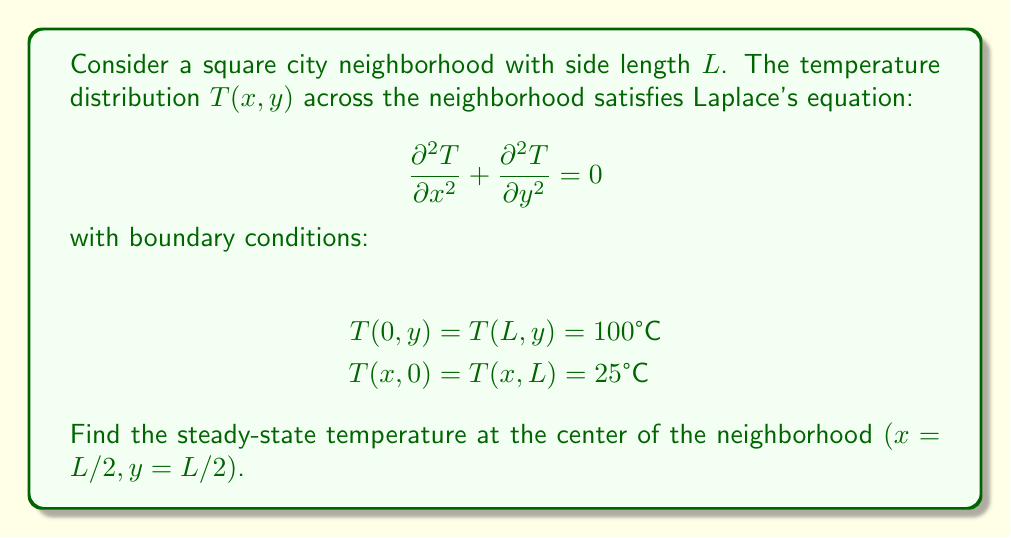What is the answer to this math problem? To solve this problem, we'll follow these steps:

1) The general solution to Laplace's equation in 2D with these boundary conditions is:

   $$T(x,y) = \sum_{n=1}^{\infty} A_n \sinh(\frac{n\pi x}{L}) \sin(\frac{n\pi y}{L}) + B_n \sinh(\frac{n\pi (L-x)}{L}) \sin(\frac{n\pi y}{L}) + C$$

   where $C = 25°C$ (the minimum temperature).

2) Apply the boundary condition $T(0,y) = T(L,y) = 100°C$:

   $$100 = C + \sum_{n=1}^{\infty} B_n \sinh(n\pi) \sin(\frac{n\pi y}{L})$$
   $$100 = C + \sum_{n=1}^{\infty} A_n \sinh(n\pi) \sin(\frac{n\pi y}{L})$$

3) This implies $A_n = B_n$ for all $n$. Let's call this common value $D_n$. Our solution becomes:

   $$T(x,y) = 25 + \sum_{n=1}^{\infty} D_n [\sinh(\frac{n\pi x}{L}) + \sinh(\frac{n\pi (L-x)}{L})] \sin(\frac{n\pi y}{L})$$

4) The coefficients $D_n$ can be found using Fourier series:

   $$D_n = \frac{2(100-25)}{L \sinh(n\pi)} \int_0^L \sin(\frac{n\pi y}{L}) dy = \frac{150}{\sinh(n\pi)} \cdot \frac{1-(-1)^n}{n\pi}$$

5) At the center of the neighborhood $(x=L/2, y=L/2)$:

   $$T(L/2,L/2) = 25 + \sum_{n=1,3,5,...}^{\infty} \frac{300}{\sinh(n\pi)} \cdot \frac{1}{n\pi} \sinh(\frac{n\pi}{2})$$

6) This series converges rapidly. The first term (n=1) gives a good approximation:

   $$T(L/2,L/2) \approx 25 + \frac{300}{\pi \sinh(\pi)} \sinh(\frac{\pi}{2}) \approx 62.5°C$$
Answer: $62.5°C$ 